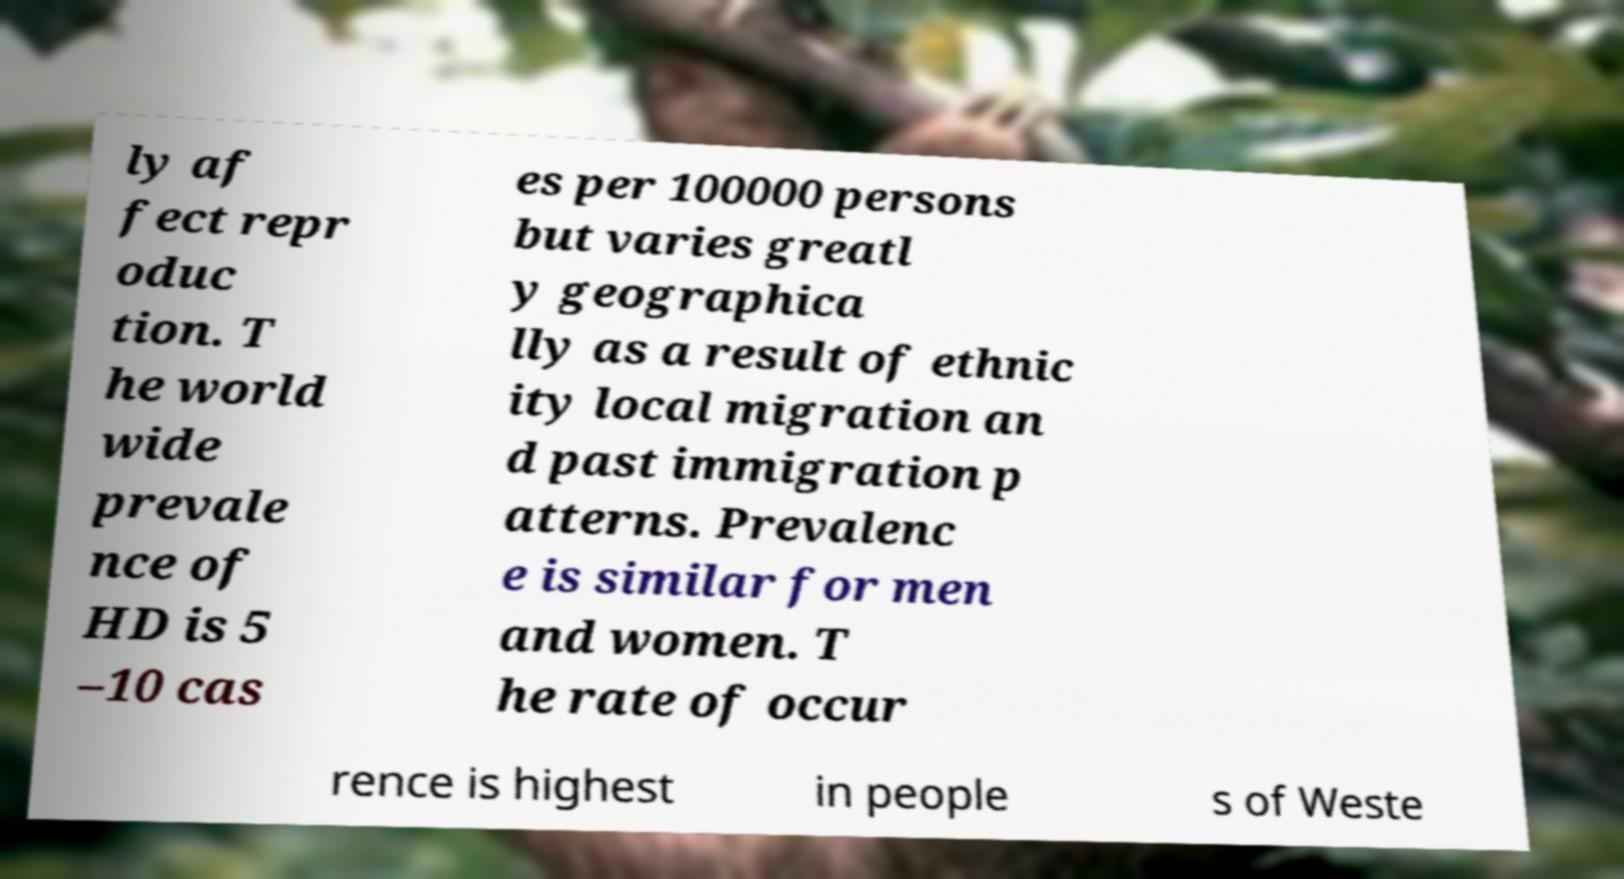Could you extract and type out the text from this image? ly af fect repr oduc tion. T he world wide prevale nce of HD is 5 –10 cas es per 100000 persons but varies greatl y geographica lly as a result of ethnic ity local migration an d past immigration p atterns. Prevalenc e is similar for men and women. T he rate of occur rence is highest in people s of Weste 